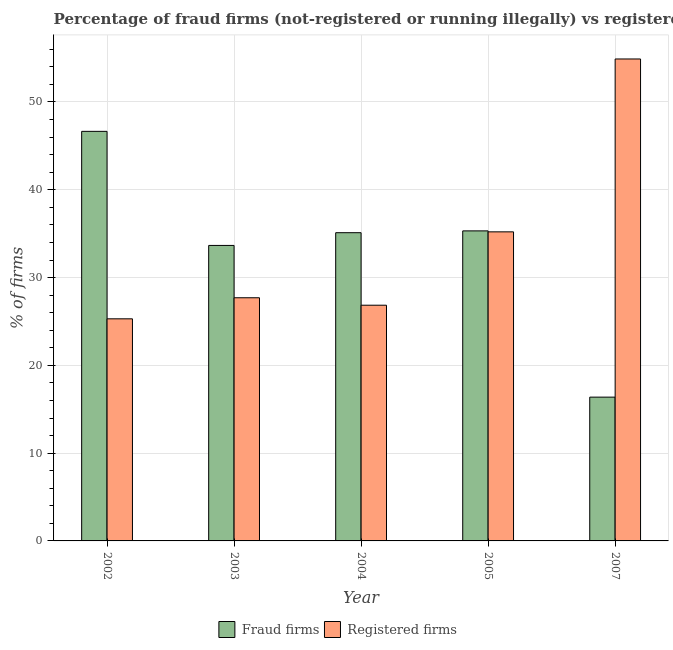Are the number of bars per tick equal to the number of legend labels?
Give a very brief answer. Yes. Are the number of bars on each tick of the X-axis equal?
Offer a terse response. Yes. How many bars are there on the 3rd tick from the left?
Your answer should be very brief. 2. How many bars are there on the 1st tick from the right?
Provide a short and direct response. 2. What is the label of the 4th group of bars from the left?
Offer a very short reply. 2005. In how many cases, is the number of bars for a given year not equal to the number of legend labels?
Provide a short and direct response. 0. What is the percentage of registered firms in 2007?
Offer a very short reply. 54.9. Across all years, what is the maximum percentage of fraud firms?
Make the answer very short. 46.65. Across all years, what is the minimum percentage of registered firms?
Give a very brief answer. 25.3. In which year was the percentage of registered firms maximum?
Provide a short and direct response. 2007. In which year was the percentage of fraud firms minimum?
Your response must be concise. 2007. What is the total percentage of fraud firms in the graph?
Your response must be concise. 167.12. What is the difference between the percentage of fraud firms in 2004 and that in 2005?
Offer a very short reply. -0.21. What is the difference between the percentage of registered firms in 2005 and the percentage of fraud firms in 2002?
Provide a short and direct response. 9.91. What is the average percentage of registered firms per year?
Make the answer very short. 33.99. In the year 2003, what is the difference between the percentage of fraud firms and percentage of registered firms?
Make the answer very short. 0. In how many years, is the percentage of fraud firms greater than 34 %?
Make the answer very short. 3. What is the ratio of the percentage of fraud firms in 2002 to that in 2004?
Provide a short and direct response. 1.33. Is the percentage of fraud firms in 2002 less than that in 2004?
Keep it short and to the point. No. What is the difference between the highest and the second highest percentage of registered firms?
Provide a short and direct response. 19.69. What is the difference between the highest and the lowest percentage of registered firms?
Your answer should be very brief. 29.6. Is the sum of the percentage of registered firms in 2004 and 2005 greater than the maximum percentage of fraud firms across all years?
Make the answer very short. Yes. What does the 2nd bar from the left in 2003 represents?
Make the answer very short. Registered firms. What does the 2nd bar from the right in 2002 represents?
Offer a very short reply. Fraud firms. How many bars are there?
Offer a terse response. 10. Are the values on the major ticks of Y-axis written in scientific E-notation?
Keep it short and to the point. No. Does the graph contain any zero values?
Your answer should be very brief. No. Where does the legend appear in the graph?
Make the answer very short. Bottom center. How are the legend labels stacked?
Your response must be concise. Horizontal. What is the title of the graph?
Offer a terse response. Percentage of fraud firms (not-registered or running illegally) vs registered firms in European Union. Does "Goods and services" appear as one of the legend labels in the graph?
Provide a succinct answer. No. What is the label or title of the X-axis?
Provide a succinct answer. Year. What is the label or title of the Y-axis?
Offer a very short reply. % of firms. What is the % of firms of Fraud firms in 2002?
Ensure brevity in your answer.  46.65. What is the % of firms of Registered firms in 2002?
Your answer should be very brief. 25.3. What is the % of firms in Fraud firms in 2003?
Provide a succinct answer. 33.66. What is the % of firms in Registered firms in 2003?
Offer a terse response. 27.7. What is the % of firms in Fraud firms in 2004?
Offer a terse response. 35.11. What is the % of firms in Registered firms in 2004?
Make the answer very short. 26.85. What is the % of firms of Fraud firms in 2005?
Ensure brevity in your answer.  35.32. What is the % of firms in Registered firms in 2005?
Offer a terse response. 35.21. What is the % of firms in Fraud firms in 2007?
Your answer should be compact. 16.38. What is the % of firms of Registered firms in 2007?
Offer a very short reply. 54.9. Across all years, what is the maximum % of firms of Fraud firms?
Offer a terse response. 46.65. Across all years, what is the maximum % of firms in Registered firms?
Offer a very short reply. 54.9. Across all years, what is the minimum % of firms of Fraud firms?
Ensure brevity in your answer.  16.38. Across all years, what is the minimum % of firms in Registered firms?
Give a very brief answer. 25.3. What is the total % of firms of Fraud firms in the graph?
Offer a very short reply. 167.12. What is the total % of firms of Registered firms in the graph?
Offer a terse response. 169.96. What is the difference between the % of firms in Fraud firms in 2002 and that in 2003?
Your answer should be very brief. 12.99. What is the difference between the % of firms of Fraud firms in 2002 and that in 2004?
Your answer should be compact. 11.54. What is the difference between the % of firms in Registered firms in 2002 and that in 2004?
Offer a very short reply. -1.55. What is the difference between the % of firms of Fraud firms in 2002 and that in 2005?
Keep it short and to the point. 11.34. What is the difference between the % of firms in Registered firms in 2002 and that in 2005?
Your answer should be very brief. -9.91. What is the difference between the % of firms in Fraud firms in 2002 and that in 2007?
Give a very brief answer. 30.27. What is the difference between the % of firms of Registered firms in 2002 and that in 2007?
Keep it short and to the point. -29.6. What is the difference between the % of firms of Fraud firms in 2003 and that in 2004?
Provide a short and direct response. -1.45. What is the difference between the % of firms of Registered firms in 2003 and that in 2004?
Provide a short and direct response. 0.85. What is the difference between the % of firms of Fraud firms in 2003 and that in 2005?
Give a very brief answer. -1.66. What is the difference between the % of firms in Registered firms in 2003 and that in 2005?
Provide a succinct answer. -7.51. What is the difference between the % of firms in Fraud firms in 2003 and that in 2007?
Provide a short and direct response. 17.28. What is the difference between the % of firms in Registered firms in 2003 and that in 2007?
Keep it short and to the point. -27.2. What is the difference between the % of firms in Fraud firms in 2004 and that in 2005?
Offer a terse response. -0.21. What is the difference between the % of firms of Registered firms in 2004 and that in 2005?
Ensure brevity in your answer.  -8.36. What is the difference between the % of firms of Fraud firms in 2004 and that in 2007?
Ensure brevity in your answer.  18.73. What is the difference between the % of firms in Registered firms in 2004 and that in 2007?
Make the answer very short. -28.05. What is the difference between the % of firms in Fraud firms in 2005 and that in 2007?
Your answer should be compact. 18.94. What is the difference between the % of firms in Registered firms in 2005 and that in 2007?
Your answer should be compact. -19.69. What is the difference between the % of firms in Fraud firms in 2002 and the % of firms in Registered firms in 2003?
Offer a very short reply. 18.95. What is the difference between the % of firms in Fraud firms in 2002 and the % of firms in Registered firms in 2004?
Ensure brevity in your answer.  19.8. What is the difference between the % of firms of Fraud firms in 2002 and the % of firms of Registered firms in 2005?
Your answer should be very brief. 11.45. What is the difference between the % of firms of Fraud firms in 2002 and the % of firms of Registered firms in 2007?
Offer a terse response. -8.25. What is the difference between the % of firms of Fraud firms in 2003 and the % of firms of Registered firms in 2004?
Your answer should be very brief. 6.81. What is the difference between the % of firms in Fraud firms in 2003 and the % of firms in Registered firms in 2005?
Provide a succinct answer. -1.55. What is the difference between the % of firms in Fraud firms in 2003 and the % of firms in Registered firms in 2007?
Your answer should be very brief. -21.24. What is the difference between the % of firms of Fraud firms in 2004 and the % of firms of Registered firms in 2005?
Provide a short and direct response. -0.1. What is the difference between the % of firms in Fraud firms in 2004 and the % of firms in Registered firms in 2007?
Keep it short and to the point. -19.79. What is the difference between the % of firms in Fraud firms in 2005 and the % of firms in Registered firms in 2007?
Ensure brevity in your answer.  -19.58. What is the average % of firms in Fraud firms per year?
Ensure brevity in your answer.  33.42. What is the average % of firms in Registered firms per year?
Your response must be concise. 33.99. In the year 2002, what is the difference between the % of firms of Fraud firms and % of firms of Registered firms?
Your answer should be compact. 21.35. In the year 2003, what is the difference between the % of firms in Fraud firms and % of firms in Registered firms?
Your answer should be very brief. 5.96. In the year 2004, what is the difference between the % of firms of Fraud firms and % of firms of Registered firms?
Keep it short and to the point. 8.26. In the year 2005, what is the difference between the % of firms of Fraud firms and % of firms of Registered firms?
Offer a very short reply. 0.11. In the year 2007, what is the difference between the % of firms in Fraud firms and % of firms in Registered firms?
Offer a terse response. -38.52. What is the ratio of the % of firms of Fraud firms in 2002 to that in 2003?
Ensure brevity in your answer.  1.39. What is the ratio of the % of firms of Registered firms in 2002 to that in 2003?
Your answer should be very brief. 0.91. What is the ratio of the % of firms in Fraud firms in 2002 to that in 2004?
Your response must be concise. 1.33. What is the ratio of the % of firms in Registered firms in 2002 to that in 2004?
Make the answer very short. 0.94. What is the ratio of the % of firms in Fraud firms in 2002 to that in 2005?
Make the answer very short. 1.32. What is the ratio of the % of firms in Registered firms in 2002 to that in 2005?
Provide a succinct answer. 0.72. What is the ratio of the % of firms in Fraud firms in 2002 to that in 2007?
Provide a short and direct response. 2.85. What is the ratio of the % of firms of Registered firms in 2002 to that in 2007?
Your answer should be compact. 0.46. What is the ratio of the % of firms of Fraud firms in 2003 to that in 2004?
Provide a succinct answer. 0.96. What is the ratio of the % of firms of Registered firms in 2003 to that in 2004?
Your response must be concise. 1.03. What is the ratio of the % of firms of Fraud firms in 2003 to that in 2005?
Ensure brevity in your answer.  0.95. What is the ratio of the % of firms in Registered firms in 2003 to that in 2005?
Ensure brevity in your answer.  0.79. What is the ratio of the % of firms of Fraud firms in 2003 to that in 2007?
Provide a short and direct response. 2.05. What is the ratio of the % of firms in Registered firms in 2003 to that in 2007?
Offer a very short reply. 0.5. What is the ratio of the % of firms of Registered firms in 2004 to that in 2005?
Provide a succinct answer. 0.76. What is the ratio of the % of firms of Fraud firms in 2004 to that in 2007?
Offer a terse response. 2.14. What is the ratio of the % of firms in Registered firms in 2004 to that in 2007?
Offer a terse response. 0.49. What is the ratio of the % of firms in Fraud firms in 2005 to that in 2007?
Your answer should be compact. 2.16. What is the ratio of the % of firms of Registered firms in 2005 to that in 2007?
Ensure brevity in your answer.  0.64. What is the difference between the highest and the second highest % of firms of Fraud firms?
Keep it short and to the point. 11.34. What is the difference between the highest and the second highest % of firms of Registered firms?
Your answer should be very brief. 19.69. What is the difference between the highest and the lowest % of firms of Fraud firms?
Your answer should be very brief. 30.27. What is the difference between the highest and the lowest % of firms in Registered firms?
Your answer should be compact. 29.6. 